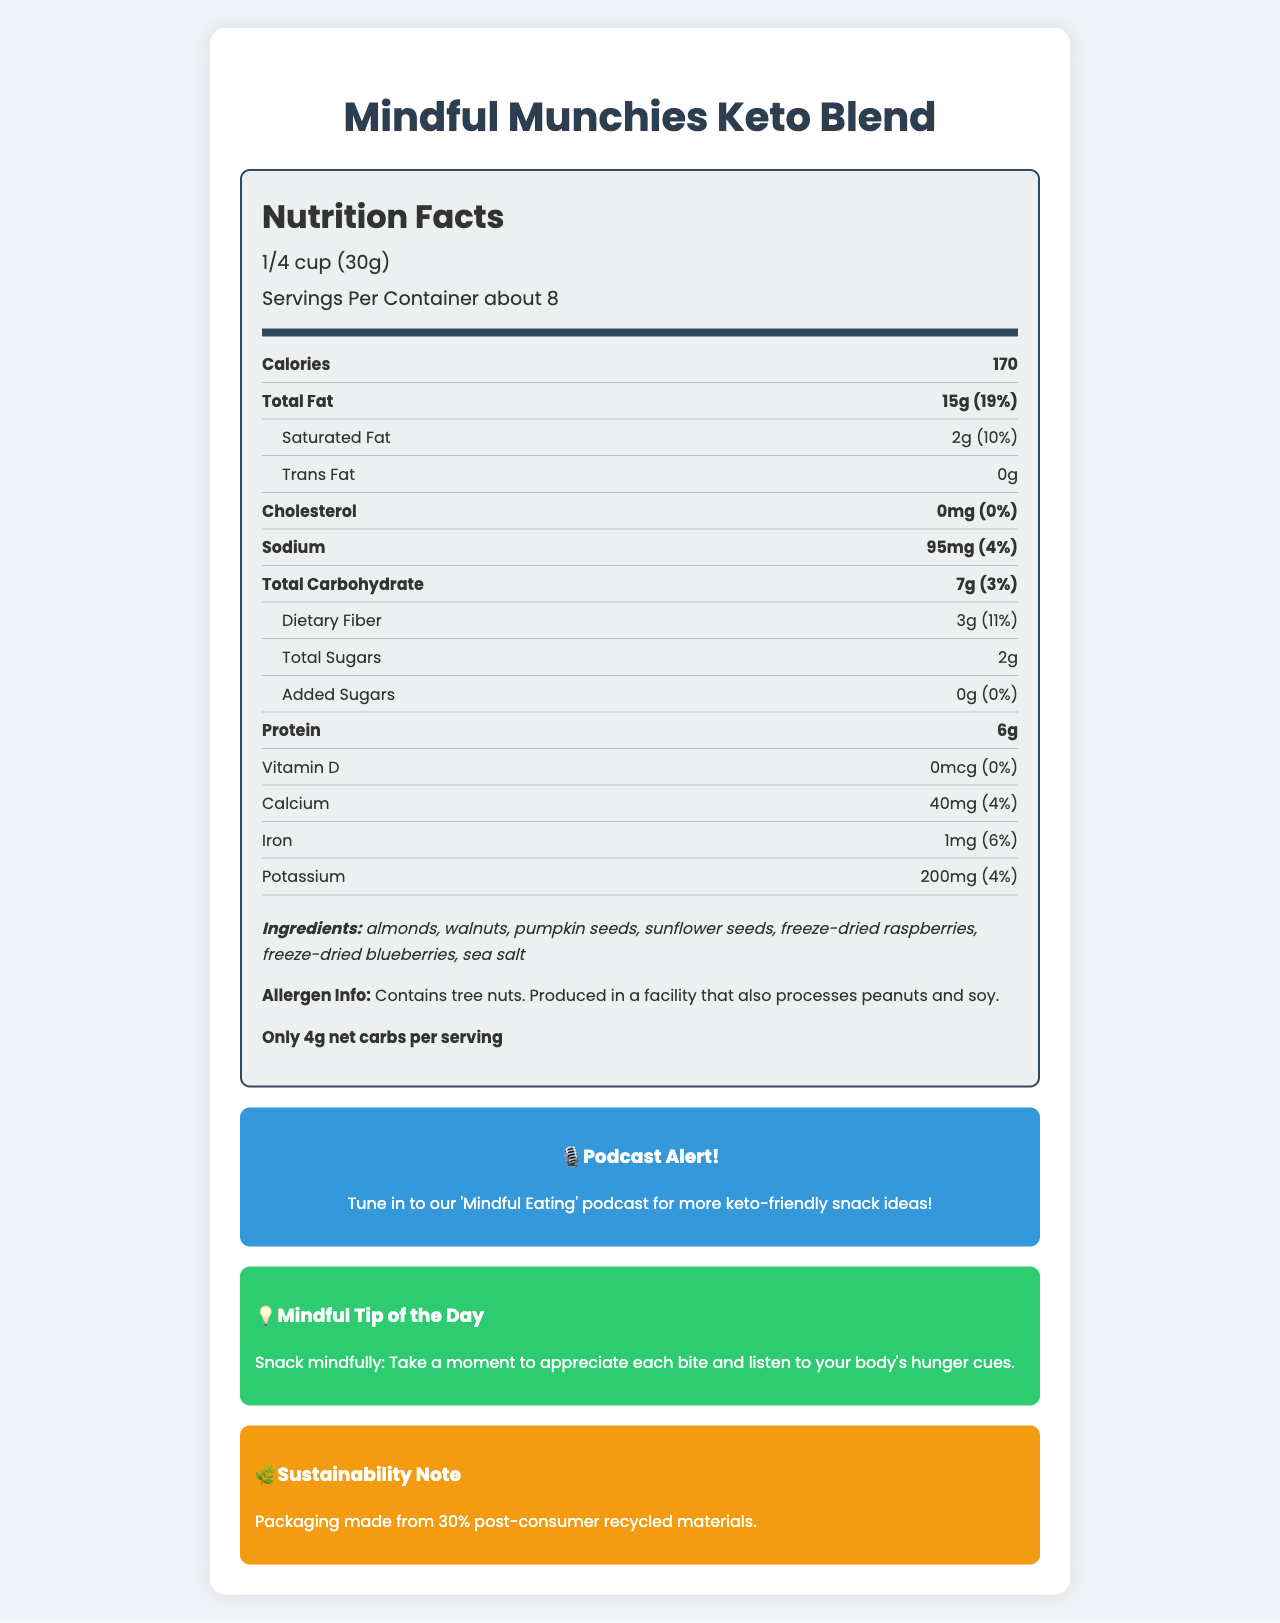what is the serving size? The serving size is clearly specified at the top of the nutrition label as "1/4 cup (30g)".
Answer: 1/4 cup (30g) how many calories are in one serving? The document lists the calories content as 170 in the detailed nutrition facts section.
Answer: 170 what are the total fat and its daily value percentage? Under the "Total Fat" category, it states that there are 15g of total fat which is 19% of the daily value.
Answer: 15g (19%) what is the amount of dietary fiber per serving? The nutrition facts mention that there are 3g of dietary fiber per serving.
Answer: 3g are there any added sugars in this product? The section for "Added Sugars" lists the amount as 0g, indicating there are no added sugars.
Answer: No how much calcium does one serving contain? In the vitamins and minerals section, it states that the product contains 40mg of calcium, which is 4% of the daily value.
Answer: 40mg (4%) which ingredient is NOT present in the snack mix? A. Almonds B. Raisins C. Pumpkin seeds D. Sea salt The ingredient list shows "almonds", "pumpkin seeds", and "sea salt" but does not mention "raisins".
Answer: B what is the daily value percentage of iron per serving? A. 2% B. 4% C. 6% D. 8% The nutrition label lists iron content as 1mg, which is 6% of the daily value.
Answer: C is this product keto-friendly? The label explicitly claims that the product is keto-friendly, with "Only 4g net carbs per serving".
Answer: Yes does this product contain trans fat? The nutrition facts section lists "0g" of trans fat.
Answer: No describe the main features highlighted about the "Mindful Munchies Keto Blend". The document details the nutritional information, ingredients, serving sizes, promotional content, and additional health and sustainability notes regarding the product.
Answer: The document presents the "Mindful Munchies Keto Blend" as a keto-friendly, low-carb snack mix. Each serving is 1/4 cup (30g) with about 8 servings per container, containing 170 calories. It is rich in fats (15g total, 2g saturated, 0g trans) and high in dietary fiber (3g) with 6g of protein. The ingredients include various nuts, seeds, and freeze-dried berries. There are no added sugars. The label also notes allergen information, recommends mindful eating practices, promotes a podcast, and highlights sustainable packaging. what is the manufacturer of the "Mindful Munchies Keto Blend"? The document does not provide any information about the manufacturer of the product.
Answer: Cannot be determined 